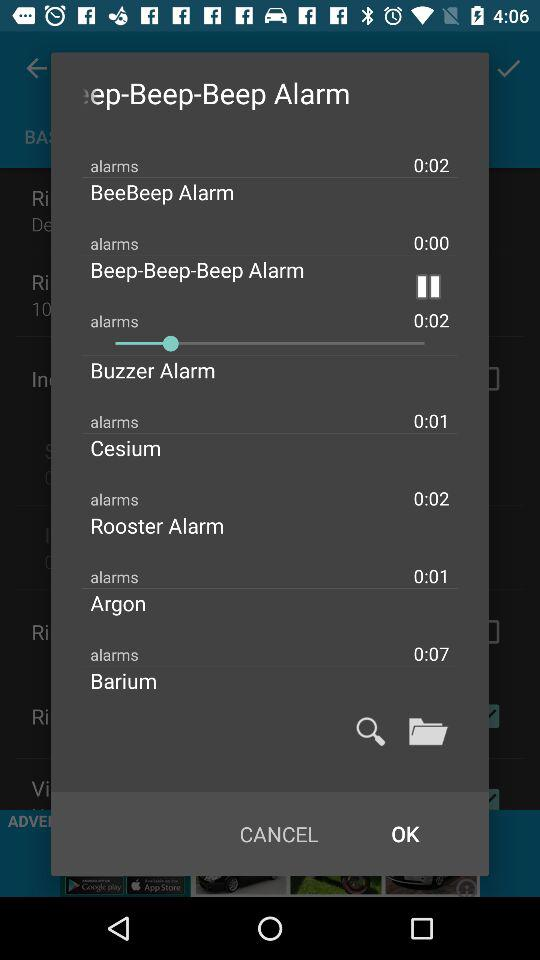What is the length of the playing alarm? The length of the playing alarm is 0:02. 